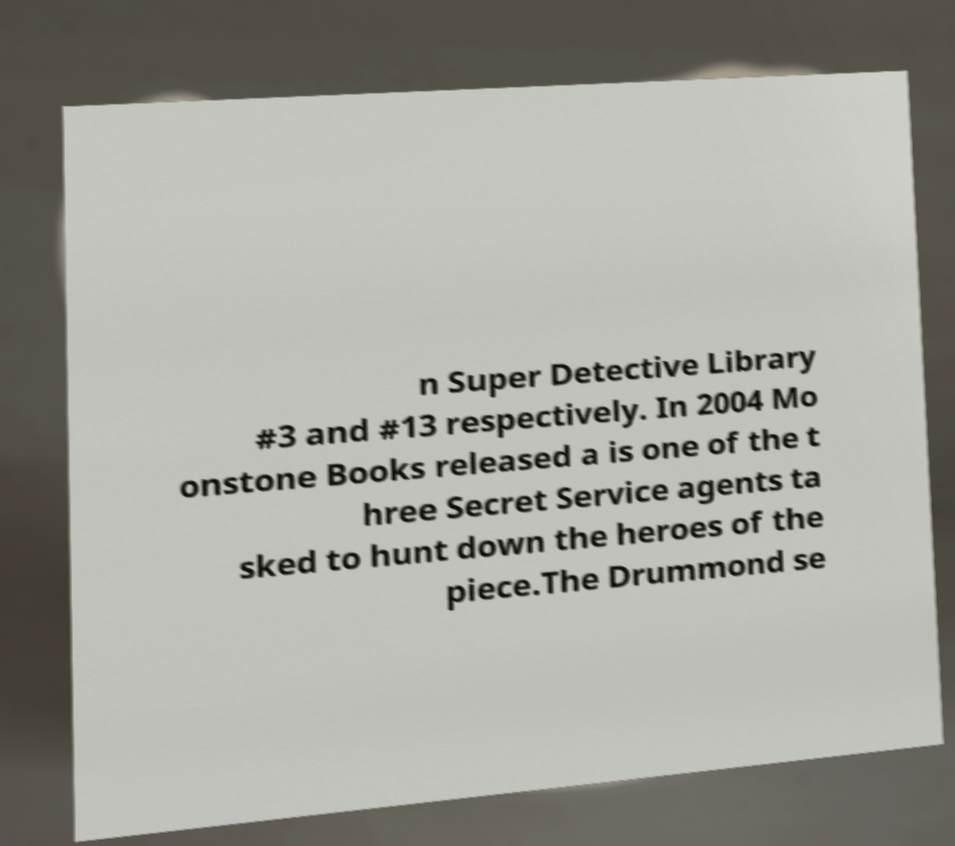What messages or text are displayed in this image? I need them in a readable, typed format. n Super Detective Library #3 and #13 respectively. In 2004 Mo onstone Books released a is one of the t hree Secret Service agents ta sked to hunt down the heroes of the piece.The Drummond se 